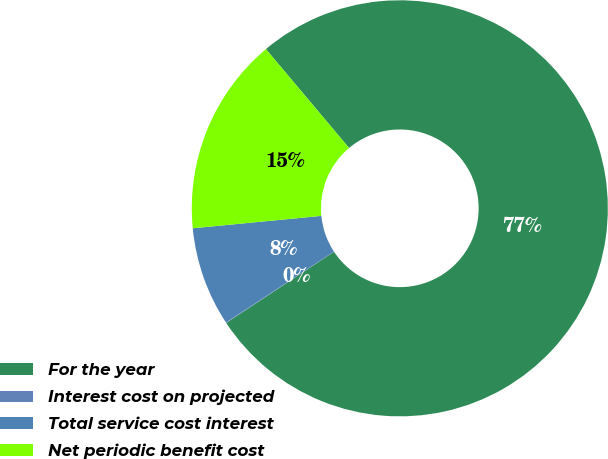Convert chart to OTSL. <chart><loc_0><loc_0><loc_500><loc_500><pie_chart><fcel>For the year<fcel>Interest cost on projected<fcel>Total service cost interest<fcel>Net periodic benefit cost<nl><fcel>76.84%<fcel>0.04%<fcel>7.72%<fcel>15.4%<nl></chart> 